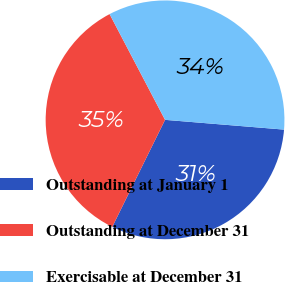<chart> <loc_0><loc_0><loc_500><loc_500><pie_chart><fcel>Outstanding at January 1<fcel>Outstanding at December 31<fcel>Exercisable at December 31<nl><fcel>30.99%<fcel>35.02%<fcel>33.99%<nl></chart> 